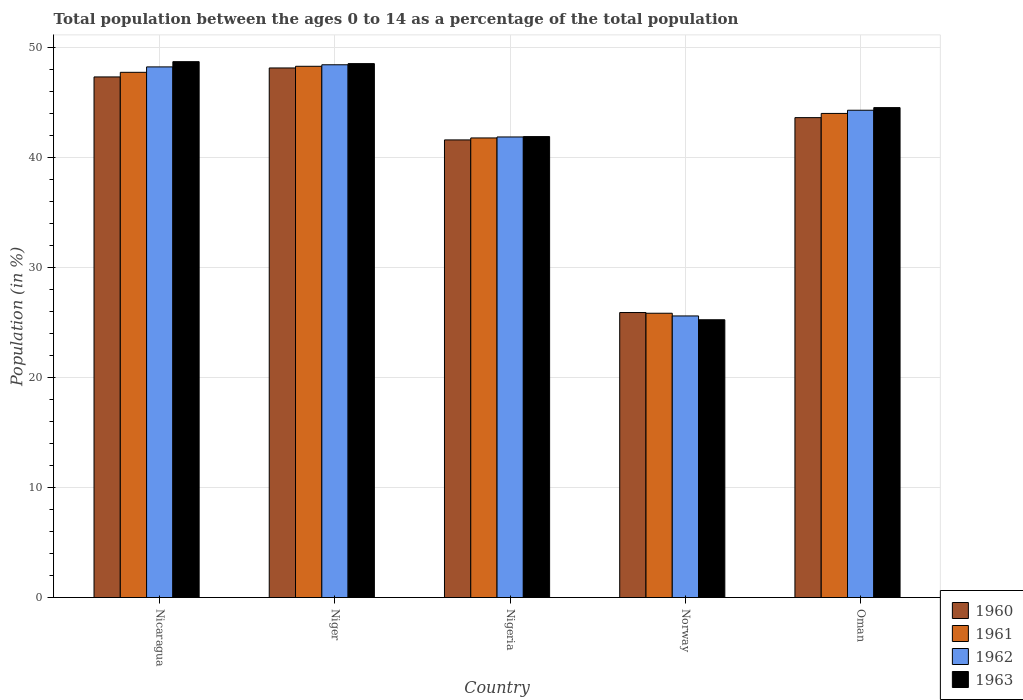Are the number of bars per tick equal to the number of legend labels?
Your response must be concise. Yes. Are the number of bars on each tick of the X-axis equal?
Provide a short and direct response. Yes. How many bars are there on the 2nd tick from the left?
Your answer should be compact. 4. What is the percentage of the population ages 0 to 14 in 1962 in Nicaragua?
Make the answer very short. 48.26. Across all countries, what is the maximum percentage of the population ages 0 to 14 in 1962?
Offer a terse response. 48.45. Across all countries, what is the minimum percentage of the population ages 0 to 14 in 1961?
Offer a terse response. 25.86. In which country was the percentage of the population ages 0 to 14 in 1960 maximum?
Ensure brevity in your answer.  Niger. What is the total percentage of the population ages 0 to 14 in 1961 in the graph?
Keep it short and to the point. 207.76. What is the difference between the percentage of the population ages 0 to 14 in 1960 in Niger and that in Oman?
Provide a short and direct response. 4.52. What is the difference between the percentage of the population ages 0 to 14 in 1963 in Niger and the percentage of the population ages 0 to 14 in 1962 in Oman?
Keep it short and to the point. 4.24. What is the average percentage of the population ages 0 to 14 in 1963 per country?
Make the answer very short. 41.81. What is the difference between the percentage of the population ages 0 to 14 of/in 1963 and percentage of the population ages 0 to 14 of/in 1960 in Norway?
Provide a succinct answer. -0.66. What is the ratio of the percentage of the population ages 0 to 14 in 1963 in Nicaragua to that in Norway?
Ensure brevity in your answer.  1.93. Is the percentage of the population ages 0 to 14 in 1960 in Nigeria less than that in Norway?
Ensure brevity in your answer.  No. What is the difference between the highest and the second highest percentage of the population ages 0 to 14 in 1961?
Keep it short and to the point. 4.29. What is the difference between the highest and the lowest percentage of the population ages 0 to 14 in 1960?
Make the answer very short. 22.24. In how many countries, is the percentage of the population ages 0 to 14 in 1961 greater than the average percentage of the population ages 0 to 14 in 1961 taken over all countries?
Provide a short and direct response. 4. Is it the case that in every country, the sum of the percentage of the population ages 0 to 14 in 1960 and percentage of the population ages 0 to 14 in 1963 is greater than the sum of percentage of the population ages 0 to 14 in 1961 and percentage of the population ages 0 to 14 in 1962?
Keep it short and to the point. No. Is it the case that in every country, the sum of the percentage of the population ages 0 to 14 in 1961 and percentage of the population ages 0 to 14 in 1962 is greater than the percentage of the population ages 0 to 14 in 1963?
Your response must be concise. Yes. How many bars are there?
Your response must be concise. 20. Are the values on the major ticks of Y-axis written in scientific E-notation?
Your response must be concise. No. How many legend labels are there?
Your answer should be very brief. 4. What is the title of the graph?
Offer a terse response. Total population between the ages 0 to 14 as a percentage of the total population. Does "1970" appear as one of the legend labels in the graph?
Ensure brevity in your answer.  No. What is the label or title of the Y-axis?
Keep it short and to the point. Population (in %). What is the Population (in %) of 1960 in Nicaragua?
Your answer should be compact. 47.35. What is the Population (in %) of 1961 in Nicaragua?
Provide a short and direct response. 47.77. What is the Population (in %) of 1962 in Nicaragua?
Offer a terse response. 48.26. What is the Population (in %) of 1963 in Nicaragua?
Keep it short and to the point. 48.74. What is the Population (in %) in 1960 in Niger?
Your answer should be very brief. 48.16. What is the Population (in %) in 1961 in Niger?
Make the answer very short. 48.32. What is the Population (in %) of 1962 in Niger?
Give a very brief answer. 48.45. What is the Population (in %) in 1963 in Niger?
Your response must be concise. 48.56. What is the Population (in %) of 1960 in Nigeria?
Keep it short and to the point. 41.62. What is the Population (in %) of 1961 in Nigeria?
Make the answer very short. 41.8. What is the Population (in %) of 1962 in Nigeria?
Make the answer very short. 41.89. What is the Population (in %) of 1963 in Nigeria?
Ensure brevity in your answer.  41.92. What is the Population (in %) in 1960 in Norway?
Offer a very short reply. 25.92. What is the Population (in %) in 1961 in Norway?
Ensure brevity in your answer.  25.86. What is the Population (in %) in 1962 in Norway?
Make the answer very short. 25.61. What is the Population (in %) in 1963 in Norway?
Make the answer very short. 25.26. What is the Population (in %) of 1960 in Oman?
Provide a succinct answer. 43.65. What is the Population (in %) in 1961 in Oman?
Offer a very short reply. 44.03. What is the Population (in %) in 1962 in Oman?
Your answer should be compact. 44.32. What is the Population (in %) in 1963 in Oman?
Provide a short and direct response. 44.56. Across all countries, what is the maximum Population (in %) in 1960?
Give a very brief answer. 48.16. Across all countries, what is the maximum Population (in %) in 1961?
Ensure brevity in your answer.  48.32. Across all countries, what is the maximum Population (in %) in 1962?
Keep it short and to the point. 48.45. Across all countries, what is the maximum Population (in %) of 1963?
Offer a very short reply. 48.74. Across all countries, what is the minimum Population (in %) of 1960?
Your answer should be very brief. 25.92. Across all countries, what is the minimum Population (in %) in 1961?
Your answer should be compact. 25.86. Across all countries, what is the minimum Population (in %) of 1962?
Offer a very short reply. 25.61. Across all countries, what is the minimum Population (in %) of 1963?
Your answer should be very brief. 25.26. What is the total Population (in %) of 1960 in the graph?
Make the answer very short. 206.69. What is the total Population (in %) of 1961 in the graph?
Ensure brevity in your answer.  207.76. What is the total Population (in %) of 1962 in the graph?
Give a very brief answer. 208.53. What is the total Population (in %) in 1963 in the graph?
Give a very brief answer. 209.04. What is the difference between the Population (in %) in 1960 in Nicaragua and that in Niger?
Provide a short and direct response. -0.82. What is the difference between the Population (in %) in 1961 in Nicaragua and that in Niger?
Keep it short and to the point. -0.55. What is the difference between the Population (in %) of 1962 in Nicaragua and that in Niger?
Offer a terse response. -0.19. What is the difference between the Population (in %) of 1963 in Nicaragua and that in Niger?
Offer a very short reply. 0.18. What is the difference between the Population (in %) in 1960 in Nicaragua and that in Nigeria?
Offer a terse response. 5.73. What is the difference between the Population (in %) in 1961 in Nicaragua and that in Nigeria?
Your answer should be compact. 5.97. What is the difference between the Population (in %) in 1962 in Nicaragua and that in Nigeria?
Make the answer very short. 6.37. What is the difference between the Population (in %) in 1963 in Nicaragua and that in Nigeria?
Offer a very short reply. 6.81. What is the difference between the Population (in %) in 1960 in Nicaragua and that in Norway?
Your answer should be compact. 21.43. What is the difference between the Population (in %) in 1961 in Nicaragua and that in Norway?
Your response must be concise. 21.91. What is the difference between the Population (in %) of 1962 in Nicaragua and that in Norway?
Ensure brevity in your answer.  22.65. What is the difference between the Population (in %) in 1963 in Nicaragua and that in Norway?
Provide a short and direct response. 23.47. What is the difference between the Population (in %) in 1960 in Nicaragua and that in Oman?
Provide a succinct answer. 3.7. What is the difference between the Population (in %) in 1961 in Nicaragua and that in Oman?
Offer a terse response. 3.74. What is the difference between the Population (in %) in 1962 in Nicaragua and that in Oman?
Ensure brevity in your answer.  3.94. What is the difference between the Population (in %) of 1963 in Nicaragua and that in Oman?
Offer a terse response. 4.18. What is the difference between the Population (in %) in 1960 in Niger and that in Nigeria?
Provide a short and direct response. 6.54. What is the difference between the Population (in %) of 1961 in Niger and that in Nigeria?
Your answer should be compact. 6.52. What is the difference between the Population (in %) of 1962 in Niger and that in Nigeria?
Your answer should be very brief. 6.57. What is the difference between the Population (in %) in 1963 in Niger and that in Nigeria?
Your response must be concise. 6.64. What is the difference between the Population (in %) in 1960 in Niger and that in Norway?
Make the answer very short. 22.24. What is the difference between the Population (in %) of 1961 in Niger and that in Norway?
Ensure brevity in your answer.  22.46. What is the difference between the Population (in %) in 1962 in Niger and that in Norway?
Ensure brevity in your answer.  22.84. What is the difference between the Population (in %) in 1963 in Niger and that in Norway?
Offer a terse response. 23.3. What is the difference between the Population (in %) in 1960 in Niger and that in Oman?
Keep it short and to the point. 4.52. What is the difference between the Population (in %) in 1961 in Niger and that in Oman?
Give a very brief answer. 4.29. What is the difference between the Population (in %) of 1962 in Niger and that in Oman?
Your answer should be compact. 4.14. What is the difference between the Population (in %) in 1963 in Niger and that in Oman?
Your answer should be very brief. 4. What is the difference between the Population (in %) in 1960 in Nigeria and that in Norway?
Offer a very short reply. 15.7. What is the difference between the Population (in %) in 1961 in Nigeria and that in Norway?
Your answer should be compact. 15.94. What is the difference between the Population (in %) in 1962 in Nigeria and that in Norway?
Provide a short and direct response. 16.28. What is the difference between the Population (in %) of 1963 in Nigeria and that in Norway?
Keep it short and to the point. 16.66. What is the difference between the Population (in %) in 1960 in Nigeria and that in Oman?
Provide a short and direct response. -2.03. What is the difference between the Population (in %) of 1961 in Nigeria and that in Oman?
Provide a short and direct response. -2.23. What is the difference between the Population (in %) of 1962 in Nigeria and that in Oman?
Offer a terse response. -2.43. What is the difference between the Population (in %) of 1963 in Nigeria and that in Oman?
Make the answer very short. -2.63. What is the difference between the Population (in %) in 1960 in Norway and that in Oman?
Offer a terse response. -17.73. What is the difference between the Population (in %) in 1961 in Norway and that in Oman?
Give a very brief answer. -18.17. What is the difference between the Population (in %) in 1962 in Norway and that in Oman?
Give a very brief answer. -18.71. What is the difference between the Population (in %) in 1963 in Norway and that in Oman?
Keep it short and to the point. -19.3. What is the difference between the Population (in %) of 1960 in Nicaragua and the Population (in %) of 1961 in Niger?
Ensure brevity in your answer.  -0.97. What is the difference between the Population (in %) in 1960 in Nicaragua and the Population (in %) in 1962 in Niger?
Your response must be concise. -1.11. What is the difference between the Population (in %) of 1960 in Nicaragua and the Population (in %) of 1963 in Niger?
Offer a very short reply. -1.21. What is the difference between the Population (in %) in 1961 in Nicaragua and the Population (in %) in 1962 in Niger?
Offer a very short reply. -0.69. What is the difference between the Population (in %) of 1961 in Nicaragua and the Population (in %) of 1963 in Niger?
Offer a very short reply. -0.79. What is the difference between the Population (in %) of 1962 in Nicaragua and the Population (in %) of 1963 in Niger?
Make the answer very short. -0.3. What is the difference between the Population (in %) in 1960 in Nicaragua and the Population (in %) in 1961 in Nigeria?
Your response must be concise. 5.55. What is the difference between the Population (in %) in 1960 in Nicaragua and the Population (in %) in 1962 in Nigeria?
Give a very brief answer. 5.46. What is the difference between the Population (in %) of 1960 in Nicaragua and the Population (in %) of 1963 in Nigeria?
Provide a short and direct response. 5.42. What is the difference between the Population (in %) of 1961 in Nicaragua and the Population (in %) of 1962 in Nigeria?
Give a very brief answer. 5.88. What is the difference between the Population (in %) in 1961 in Nicaragua and the Population (in %) in 1963 in Nigeria?
Make the answer very short. 5.84. What is the difference between the Population (in %) of 1962 in Nicaragua and the Population (in %) of 1963 in Nigeria?
Provide a short and direct response. 6.34. What is the difference between the Population (in %) in 1960 in Nicaragua and the Population (in %) in 1961 in Norway?
Give a very brief answer. 21.49. What is the difference between the Population (in %) in 1960 in Nicaragua and the Population (in %) in 1962 in Norway?
Your answer should be compact. 21.74. What is the difference between the Population (in %) in 1960 in Nicaragua and the Population (in %) in 1963 in Norway?
Your answer should be compact. 22.08. What is the difference between the Population (in %) of 1961 in Nicaragua and the Population (in %) of 1962 in Norway?
Offer a terse response. 22.16. What is the difference between the Population (in %) in 1961 in Nicaragua and the Population (in %) in 1963 in Norway?
Provide a short and direct response. 22.5. What is the difference between the Population (in %) of 1962 in Nicaragua and the Population (in %) of 1963 in Norway?
Your answer should be compact. 23. What is the difference between the Population (in %) in 1960 in Nicaragua and the Population (in %) in 1961 in Oman?
Offer a terse response. 3.32. What is the difference between the Population (in %) in 1960 in Nicaragua and the Population (in %) in 1962 in Oman?
Provide a short and direct response. 3.03. What is the difference between the Population (in %) in 1960 in Nicaragua and the Population (in %) in 1963 in Oman?
Give a very brief answer. 2.79. What is the difference between the Population (in %) of 1961 in Nicaragua and the Population (in %) of 1962 in Oman?
Make the answer very short. 3.45. What is the difference between the Population (in %) of 1961 in Nicaragua and the Population (in %) of 1963 in Oman?
Offer a terse response. 3.21. What is the difference between the Population (in %) of 1962 in Nicaragua and the Population (in %) of 1963 in Oman?
Keep it short and to the point. 3.7. What is the difference between the Population (in %) of 1960 in Niger and the Population (in %) of 1961 in Nigeria?
Give a very brief answer. 6.37. What is the difference between the Population (in %) of 1960 in Niger and the Population (in %) of 1962 in Nigeria?
Provide a short and direct response. 6.28. What is the difference between the Population (in %) in 1960 in Niger and the Population (in %) in 1963 in Nigeria?
Your answer should be very brief. 6.24. What is the difference between the Population (in %) in 1961 in Niger and the Population (in %) in 1962 in Nigeria?
Give a very brief answer. 6.43. What is the difference between the Population (in %) of 1961 in Niger and the Population (in %) of 1963 in Nigeria?
Provide a short and direct response. 6.39. What is the difference between the Population (in %) of 1962 in Niger and the Population (in %) of 1963 in Nigeria?
Keep it short and to the point. 6.53. What is the difference between the Population (in %) in 1960 in Niger and the Population (in %) in 1961 in Norway?
Provide a succinct answer. 22.31. What is the difference between the Population (in %) of 1960 in Niger and the Population (in %) of 1962 in Norway?
Make the answer very short. 22.55. What is the difference between the Population (in %) of 1960 in Niger and the Population (in %) of 1963 in Norway?
Give a very brief answer. 22.9. What is the difference between the Population (in %) in 1961 in Niger and the Population (in %) in 1962 in Norway?
Make the answer very short. 22.71. What is the difference between the Population (in %) in 1961 in Niger and the Population (in %) in 1963 in Norway?
Your response must be concise. 23.05. What is the difference between the Population (in %) of 1962 in Niger and the Population (in %) of 1963 in Norway?
Give a very brief answer. 23.19. What is the difference between the Population (in %) of 1960 in Niger and the Population (in %) of 1961 in Oman?
Keep it short and to the point. 4.14. What is the difference between the Population (in %) of 1960 in Niger and the Population (in %) of 1962 in Oman?
Your answer should be very brief. 3.85. What is the difference between the Population (in %) of 1960 in Niger and the Population (in %) of 1963 in Oman?
Offer a terse response. 3.61. What is the difference between the Population (in %) in 1961 in Niger and the Population (in %) in 1962 in Oman?
Keep it short and to the point. 4. What is the difference between the Population (in %) of 1961 in Niger and the Population (in %) of 1963 in Oman?
Keep it short and to the point. 3.76. What is the difference between the Population (in %) of 1962 in Niger and the Population (in %) of 1963 in Oman?
Your answer should be very brief. 3.9. What is the difference between the Population (in %) in 1960 in Nigeria and the Population (in %) in 1961 in Norway?
Offer a terse response. 15.76. What is the difference between the Population (in %) in 1960 in Nigeria and the Population (in %) in 1962 in Norway?
Give a very brief answer. 16.01. What is the difference between the Population (in %) in 1960 in Nigeria and the Population (in %) in 1963 in Norway?
Provide a short and direct response. 16.36. What is the difference between the Population (in %) in 1961 in Nigeria and the Population (in %) in 1962 in Norway?
Ensure brevity in your answer.  16.19. What is the difference between the Population (in %) of 1961 in Nigeria and the Population (in %) of 1963 in Norway?
Keep it short and to the point. 16.54. What is the difference between the Population (in %) in 1962 in Nigeria and the Population (in %) in 1963 in Norway?
Offer a terse response. 16.63. What is the difference between the Population (in %) in 1960 in Nigeria and the Population (in %) in 1961 in Oman?
Your answer should be very brief. -2.41. What is the difference between the Population (in %) of 1960 in Nigeria and the Population (in %) of 1962 in Oman?
Your response must be concise. -2.7. What is the difference between the Population (in %) of 1960 in Nigeria and the Population (in %) of 1963 in Oman?
Offer a terse response. -2.94. What is the difference between the Population (in %) in 1961 in Nigeria and the Population (in %) in 1962 in Oman?
Provide a succinct answer. -2.52. What is the difference between the Population (in %) of 1961 in Nigeria and the Population (in %) of 1963 in Oman?
Keep it short and to the point. -2.76. What is the difference between the Population (in %) in 1962 in Nigeria and the Population (in %) in 1963 in Oman?
Your answer should be very brief. -2.67. What is the difference between the Population (in %) in 1960 in Norway and the Population (in %) in 1961 in Oman?
Ensure brevity in your answer.  -18.11. What is the difference between the Population (in %) in 1960 in Norway and the Population (in %) in 1962 in Oman?
Offer a terse response. -18.4. What is the difference between the Population (in %) in 1960 in Norway and the Population (in %) in 1963 in Oman?
Keep it short and to the point. -18.64. What is the difference between the Population (in %) of 1961 in Norway and the Population (in %) of 1962 in Oman?
Offer a very short reply. -18.46. What is the difference between the Population (in %) of 1961 in Norway and the Population (in %) of 1963 in Oman?
Offer a terse response. -18.7. What is the difference between the Population (in %) of 1962 in Norway and the Population (in %) of 1963 in Oman?
Your response must be concise. -18.95. What is the average Population (in %) of 1960 per country?
Offer a very short reply. 41.34. What is the average Population (in %) of 1961 per country?
Ensure brevity in your answer.  41.55. What is the average Population (in %) in 1962 per country?
Ensure brevity in your answer.  41.71. What is the average Population (in %) in 1963 per country?
Offer a very short reply. 41.81. What is the difference between the Population (in %) in 1960 and Population (in %) in 1961 in Nicaragua?
Make the answer very short. -0.42. What is the difference between the Population (in %) of 1960 and Population (in %) of 1962 in Nicaragua?
Keep it short and to the point. -0.91. What is the difference between the Population (in %) in 1960 and Population (in %) in 1963 in Nicaragua?
Your response must be concise. -1.39. What is the difference between the Population (in %) of 1961 and Population (in %) of 1962 in Nicaragua?
Your response must be concise. -0.49. What is the difference between the Population (in %) of 1961 and Population (in %) of 1963 in Nicaragua?
Give a very brief answer. -0.97. What is the difference between the Population (in %) of 1962 and Population (in %) of 1963 in Nicaragua?
Give a very brief answer. -0.48. What is the difference between the Population (in %) in 1960 and Population (in %) in 1961 in Niger?
Make the answer very short. -0.15. What is the difference between the Population (in %) of 1960 and Population (in %) of 1962 in Niger?
Keep it short and to the point. -0.29. What is the difference between the Population (in %) of 1960 and Population (in %) of 1963 in Niger?
Your response must be concise. -0.39. What is the difference between the Population (in %) of 1961 and Population (in %) of 1962 in Niger?
Keep it short and to the point. -0.14. What is the difference between the Population (in %) in 1961 and Population (in %) in 1963 in Niger?
Offer a very short reply. -0.24. What is the difference between the Population (in %) in 1962 and Population (in %) in 1963 in Niger?
Provide a succinct answer. -0.1. What is the difference between the Population (in %) in 1960 and Population (in %) in 1961 in Nigeria?
Offer a very short reply. -0.18. What is the difference between the Population (in %) of 1960 and Population (in %) of 1962 in Nigeria?
Make the answer very short. -0.27. What is the difference between the Population (in %) of 1960 and Population (in %) of 1963 in Nigeria?
Your answer should be compact. -0.3. What is the difference between the Population (in %) in 1961 and Population (in %) in 1962 in Nigeria?
Ensure brevity in your answer.  -0.09. What is the difference between the Population (in %) in 1961 and Population (in %) in 1963 in Nigeria?
Provide a short and direct response. -0.12. What is the difference between the Population (in %) in 1962 and Population (in %) in 1963 in Nigeria?
Keep it short and to the point. -0.03. What is the difference between the Population (in %) in 1960 and Population (in %) in 1961 in Norway?
Your answer should be very brief. 0.06. What is the difference between the Population (in %) of 1960 and Population (in %) of 1962 in Norway?
Provide a short and direct response. 0.31. What is the difference between the Population (in %) in 1960 and Population (in %) in 1963 in Norway?
Provide a short and direct response. 0.66. What is the difference between the Population (in %) of 1961 and Population (in %) of 1962 in Norway?
Keep it short and to the point. 0.25. What is the difference between the Population (in %) of 1961 and Population (in %) of 1963 in Norway?
Your answer should be compact. 0.59. What is the difference between the Population (in %) of 1962 and Population (in %) of 1963 in Norway?
Provide a short and direct response. 0.35. What is the difference between the Population (in %) in 1960 and Population (in %) in 1961 in Oman?
Ensure brevity in your answer.  -0.38. What is the difference between the Population (in %) in 1960 and Population (in %) in 1962 in Oman?
Your response must be concise. -0.67. What is the difference between the Population (in %) in 1960 and Population (in %) in 1963 in Oman?
Provide a succinct answer. -0.91. What is the difference between the Population (in %) of 1961 and Population (in %) of 1962 in Oman?
Provide a short and direct response. -0.29. What is the difference between the Population (in %) of 1961 and Population (in %) of 1963 in Oman?
Offer a very short reply. -0.53. What is the difference between the Population (in %) of 1962 and Population (in %) of 1963 in Oman?
Offer a very short reply. -0.24. What is the ratio of the Population (in %) of 1961 in Nicaragua to that in Niger?
Offer a terse response. 0.99. What is the ratio of the Population (in %) in 1962 in Nicaragua to that in Niger?
Your answer should be compact. 1. What is the ratio of the Population (in %) of 1963 in Nicaragua to that in Niger?
Your answer should be compact. 1. What is the ratio of the Population (in %) of 1960 in Nicaragua to that in Nigeria?
Keep it short and to the point. 1.14. What is the ratio of the Population (in %) in 1961 in Nicaragua to that in Nigeria?
Offer a terse response. 1.14. What is the ratio of the Population (in %) in 1962 in Nicaragua to that in Nigeria?
Your response must be concise. 1.15. What is the ratio of the Population (in %) in 1963 in Nicaragua to that in Nigeria?
Offer a terse response. 1.16. What is the ratio of the Population (in %) of 1960 in Nicaragua to that in Norway?
Provide a short and direct response. 1.83. What is the ratio of the Population (in %) of 1961 in Nicaragua to that in Norway?
Ensure brevity in your answer.  1.85. What is the ratio of the Population (in %) of 1962 in Nicaragua to that in Norway?
Make the answer very short. 1.88. What is the ratio of the Population (in %) in 1963 in Nicaragua to that in Norway?
Offer a very short reply. 1.93. What is the ratio of the Population (in %) in 1960 in Nicaragua to that in Oman?
Provide a succinct answer. 1.08. What is the ratio of the Population (in %) of 1961 in Nicaragua to that in Oman?
Your answer should be very brief. 1.08. What is the ratio of the Population (in %) of 1962 in Nicaragua to that in Oman?
Offer a terse response. 1.09. What is the ratio of the Population (in %) of 1963 in Nicaragua to that in Oman?
Provide a succinct answer. 1.09. What is the ratio of the Population (in %) in 1960 in Niger to that in Nigeria?
Your response must be concise. 1.16. What is the ratio of the Population (in %) of 1961 in Niger to that in Nigeria?
Make the answer very short. 1.16. What is the ratio of the Population (in %) in 1962 in Niger to that in Nigeria?
Offer a terse response. 1.16. What is the ratio of the Population (in %) in 1963 in Niger to that in Nigeria?
Your answer should be very brief. 1.16. What is the ratio of the Population (in %) in 1960 in Niger to that in Norway?
Your answer should be very brief. 1.86. What is the ratio of the Population (in %) in 1961 in Niger to that in Norway?
Provide a succinct answer. 1.87. What is the ratio of the Population (in %) in 1962 in Niger to that in Norway?
Your response must be concise. 1.89. What is the ratio of the Population (in %) in 1963 in Niger to that in Norway?
Offer a very short reply. 1.92. What is the ratio of the Population (in %) of 1960 in Niger to that in Oman?
Offer a terse response. 1.1. What is the ratio of the Population (in %) in 1961 in Niger to that in Oman?
Offer a terse response. 1.1. What is the ratio of the Population (in %) in 1962 in Niger to that in Oman?
Provide a succinct answer. 1.09. What is the ratio of the Population (in %) of 1963 in Niger to that in Oman?
Ensure brevity in your answer.  1.09. What is the ratio of the Population (in %) of 1960 in Nigeria to that in Norway?
Provide a succinct answer. 1.61. What is the ratio of the Population (in %) in 1961 in Nigeria to that in Norway?
Offer a terse response. 1.62. What is the ratio of the Population (in %) of 1962 in Nigeria to that in Norway?
Your response must be concise. 1.64. What is the ratio of the Population (in %) of 1963 in Nigeria to that in Norway?
Offer a very short reply. 1.66. What is the ratio of the Population (in %) in 1960 in Nigeria to that in Oman?
Your answer should be very brief. 0.95. What is the ratio of the Population (in %) in 1961 in Nigeria to that in Oman?
Provide a short and direct response. 0.95. What is the ratio of the Population (in %) of 1962 in Nigeria to that in Oman?
Provide a succinct answer. 0.95. What is the ratio of the Population (in %) in 1963 in Nigeria to that in Oman?
Your answer should be very brief. 0.94. What is the ratio of the Population (in %) in 1960 in Norway to that in Oman?
Give a very brief answer. 0.59. What is the ratio of the Population (in %) of 1961 in Norway to that in Oman?
Keep it short and to the point. 0.59. What is the ratio of the Population (in %) in 1962 in Norway to that in Oman?
Provide a short and direct response. 0.58. What is the ratio of the Population (in %) of 1963 in Norway to that in Oman?
Keep it short and to the point. 0.57. What is the difference between the highest and the second highest Population (in %) of 1960?
Your answer should be very brief. 0.82. What is the difference between the highest and the second highest Population (in %) in 1961?
Offer a terse response. 0.55. What is the difference between the highest and the second highest Population (in %) in 1962?
Your answer should be compact. 0.19. What is the difference between the highest and the second highest Population (in %) in 1963?
Provide a short and direct response. 0.18. What is the difference between the highest and the lowest Population (in %) in 1960?
Your answer should be very brief. 22.24. What is the difference between the highest and the lowest Population (in %) of 1961?
Provide a succinct answer. 22.46. What is the difference between the highest and the lowest Population (in %) of 1962?
Offer a terse response. 22.84. What is the difference between the highest and the lowest Population (in %) in 1963?
Make the answer very short. 23.47. 